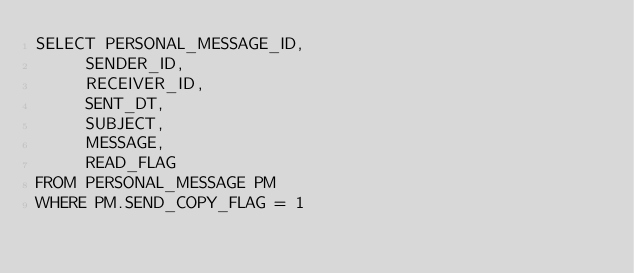Convert code to text. <code><loc_0><loc_0><loc_500><loc_500><_SQL_>SELECT PERSONAL_MESSAGE_ID,
	   SENDER_ID,
	   RECEIVER_ID,
	   SENT_DT,
	   SUBJECT,
	   MESSAGE,
	   READ_FLAG
FROM PERSONAL_MESSAGE PM
WHERE PM.SEND_COPY_FLAG = 1</code> 